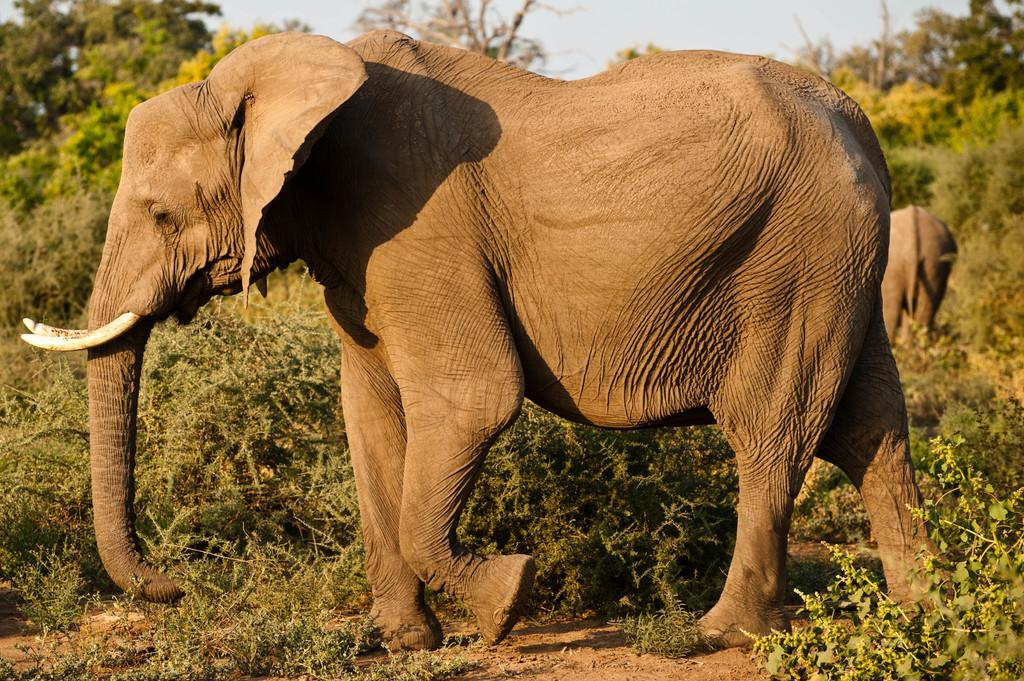What animals are present in the image? There are elephants in the image. What can be seen in the background of the image? There are trees and the sky visible in the background of the image. What type of button can be seen on the elephant's trunk in the image? There is no button present on the elephant's trunk in the image. 